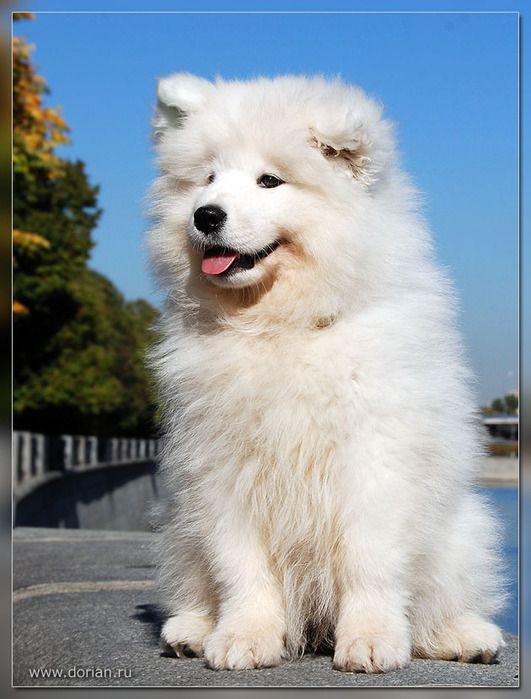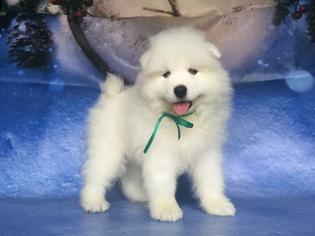The first image is the image on the left, the second image is the image on the right. Given the left and right images, does the statement "At least one dog is standing on asphalt." hold true? Answer yes or no. Yes. 